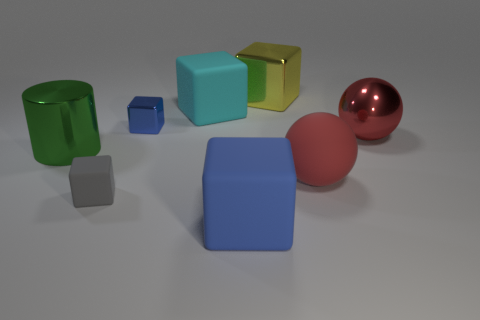Is there anything else of the same color as the cylinder?
Keep it short and to the point. No. Is there another green shiny cylinder that has the same size as the green metal cylinder?
Your response must be concise. No. What size is the cyan object that is made of the same material as the gray object?
Provide a short and direct response. Large. What is the shape of the green shiny thing?
Give a very brief answer. Cylinder. Do the gray block and the red object that is right of the matte ball have the same material?
Give a very brief answer. No. How many objects are blue matte cubes or big green metallic things?
Provide a short and direct response. 2. Is there a blue cube?
Ensure brevity in your answer.  Yes. The rubber thing to the right of the cube that is to the right of the blue rubber block is what shape?
Make the answer very short. Sphere. What number of objects are things right of the small gray cube or blue cubes behind the small gray rubber object?
Your answer should be compact. 6. There is a yellow block that is the same size as the green shiny cylinder; what is its material?
Make the answer very short. Metal. 